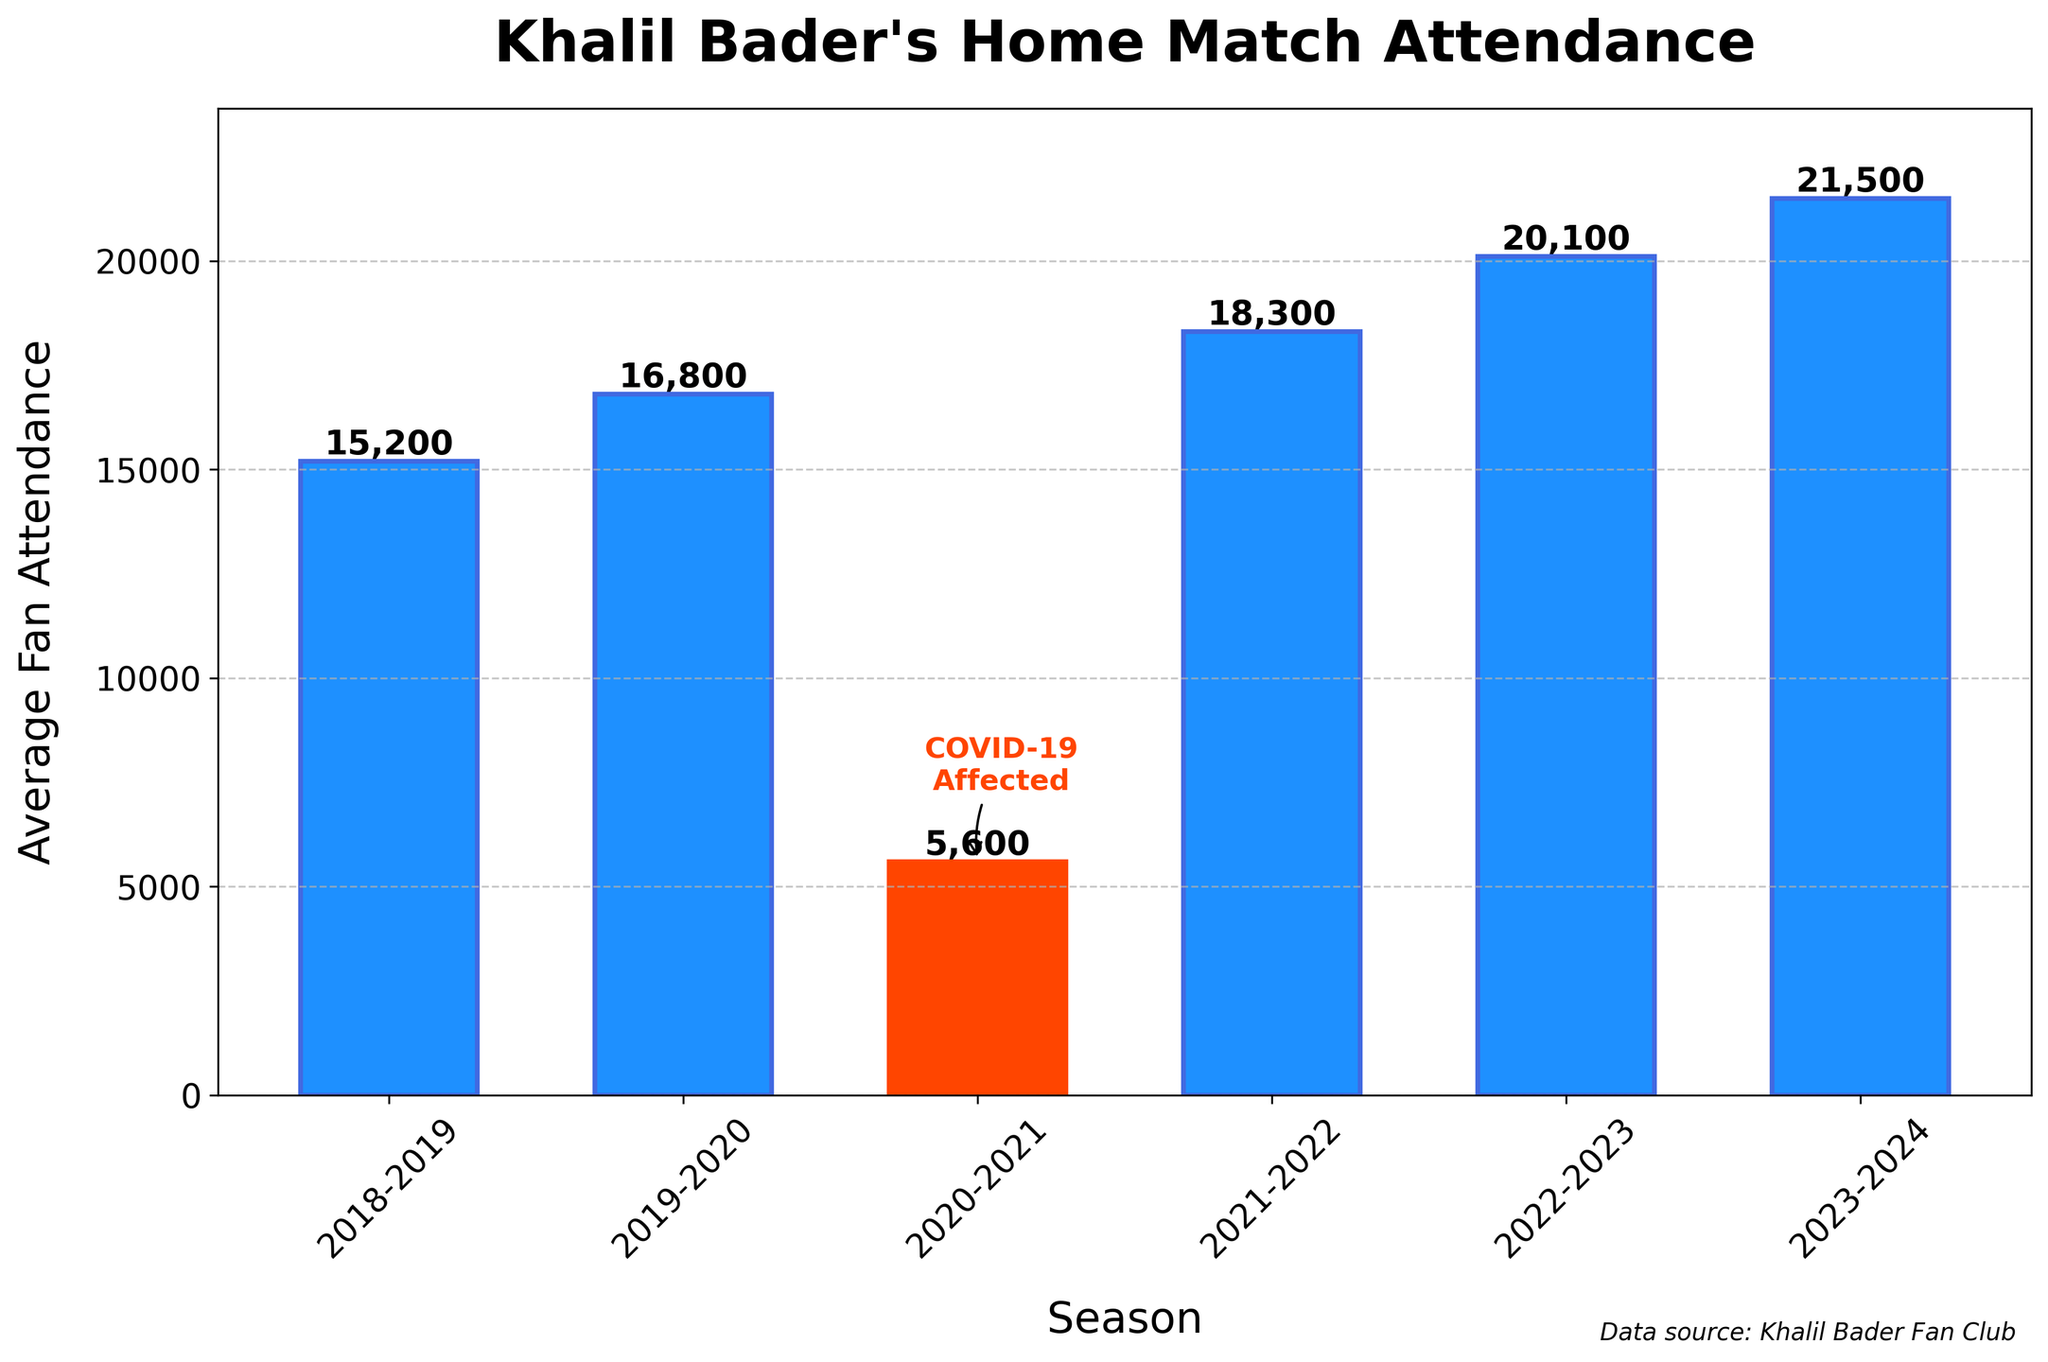What is the average fan attendance for the 2022-2023 season? The height of the bar representing the average fan attendance for the 2022-2023 season is labeled directly on the bar itself.
Answer: 20100 Between which two consecutive seasons did Khalil Bader's home match attendance see the greatest increase? Compare the differences in attendance between adjacent seasons. The increase from 2021-2022 to 2022-2023 is larger than others.
Answer: 2021-2022 to 2022-2023 During which season was the average attendance the lowest, and what might have caused this? The shortest bar represents the 2020-2021 season, and a visual annotation indicates it was affected by COVID-19.
Answer: 2020-2021, COVID-19 Which two seasons had the closest average fan attendance? The 2018-2019 and 2019-2020 seasons have the closest heights among the bars.
Answer: 2018-2019 and 2019-2020 By how much did the average attendance change from 2018-2019 to 2023-2024 season? Subtract the 2018-2019 value from the 2023-2024 value: 21500 - 15200.
Answer: 6300 Which season saw the highest average fan attendance, and how do you know? The tallest bar, labeled 21500, corresponds to the 2023-2024 season.
Answer: 2023-2024 Calculate the average fan attendance over all seasons. Sum all the attendance values and divide by the number of seasons: (15200 + 16800 + 5600 + 18300 + 20100 + 21500) / 6.
Answer: 16250 How did the attendance trend from 2018-2019 to 2023-2024? Note the general direction of the bars' heights from left to right; attendance increases except for a dip in 2020-2021.
Answer: Increasing except 2020-2021 What was the fan attendance difference between the seasons of 2020-2021 and 2021-2022? Subtract the 2020-2021 value from the 2021-2022 value: 18300 - 5600.
Answer: 12700 Is there any season where the attendance change from the previous season was less than 2000? Subtract each season's attendance from the previous season's value and check the differences; 15200 to 16800 has a change of 1600.
Answer: Yes, 2018-2019 to 2019-2020 